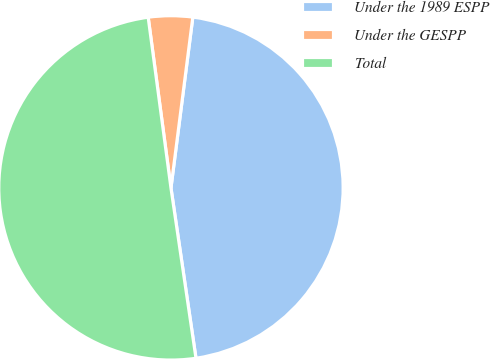<chart> <loc_0><loc_0><loc_500><loc_500><pie_chart><fcel>Under the 1989 ESPP<fcel>Under the GESPP<fcel>Total<nl><fcel>45.65%<fcel>4.14%<fcel>50.21%<nl></chart> 